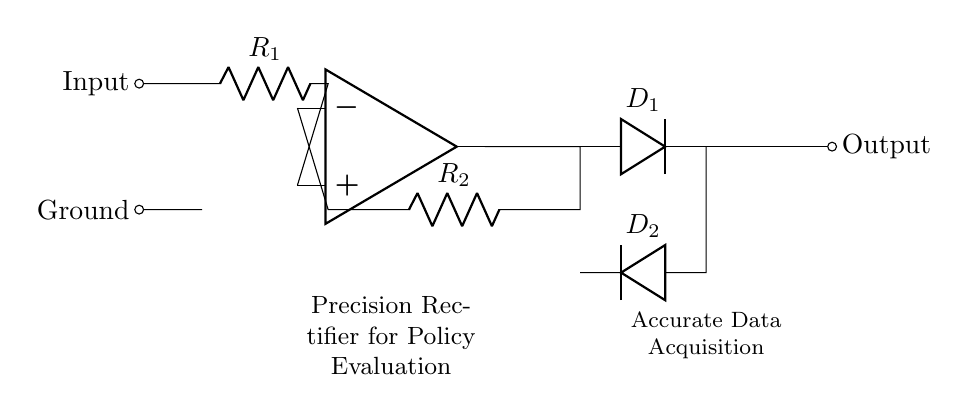What type of diodes are used in the circuit? The circuit uses two diodes, labeled D1 and D2, as indicated in the diagram. D1 is oriented to allow current flow in one direction, while D2 is inverted to allow current flow in the opposite direction.
Answer: D1 and D2 What is the function of the operational amplifier in this circuit? The operational amplifier amplifies the input signal, allowing for precise rectification of both positive and negative portions of the input waveform, which is essential for accurate data acquisition.
Answer: Precision rectification What are the resistance values in the circuit? The resistances are labeled R1 and R2, but their specific values are not provided in the diagram. They can be determined when designing the circuit based on application requirements.
Answer: Not specified How many resistors are present in the circuit? The circuit contains two resistors, R1 and R2, which are part of the feedback mechanism to stabilize the operational amplifier's output.
Answer: Two What is the primary purpose of this precision rectifier circuit? The primary purpose of the precision rectifier circuit is to accurately convert both positive and negative input signals into a unidirectional output, which is critical for data acquisition in policy evaluation systems.
Answer: Accurate data acquisition Which components are responsible for allowing current to flow in one direction? Diodes D1 and D2 are the components that allow current to flow in one direction; they provide the necessary rectification of the input signal.
Answer: Diodes D1 and D2 What connects the output of the operational amplifier to the diodes? The output of the operational amplifier is connected to the junction leading to the diodes through a wire, facilitating the rectification process.
Answer: Wire connection 